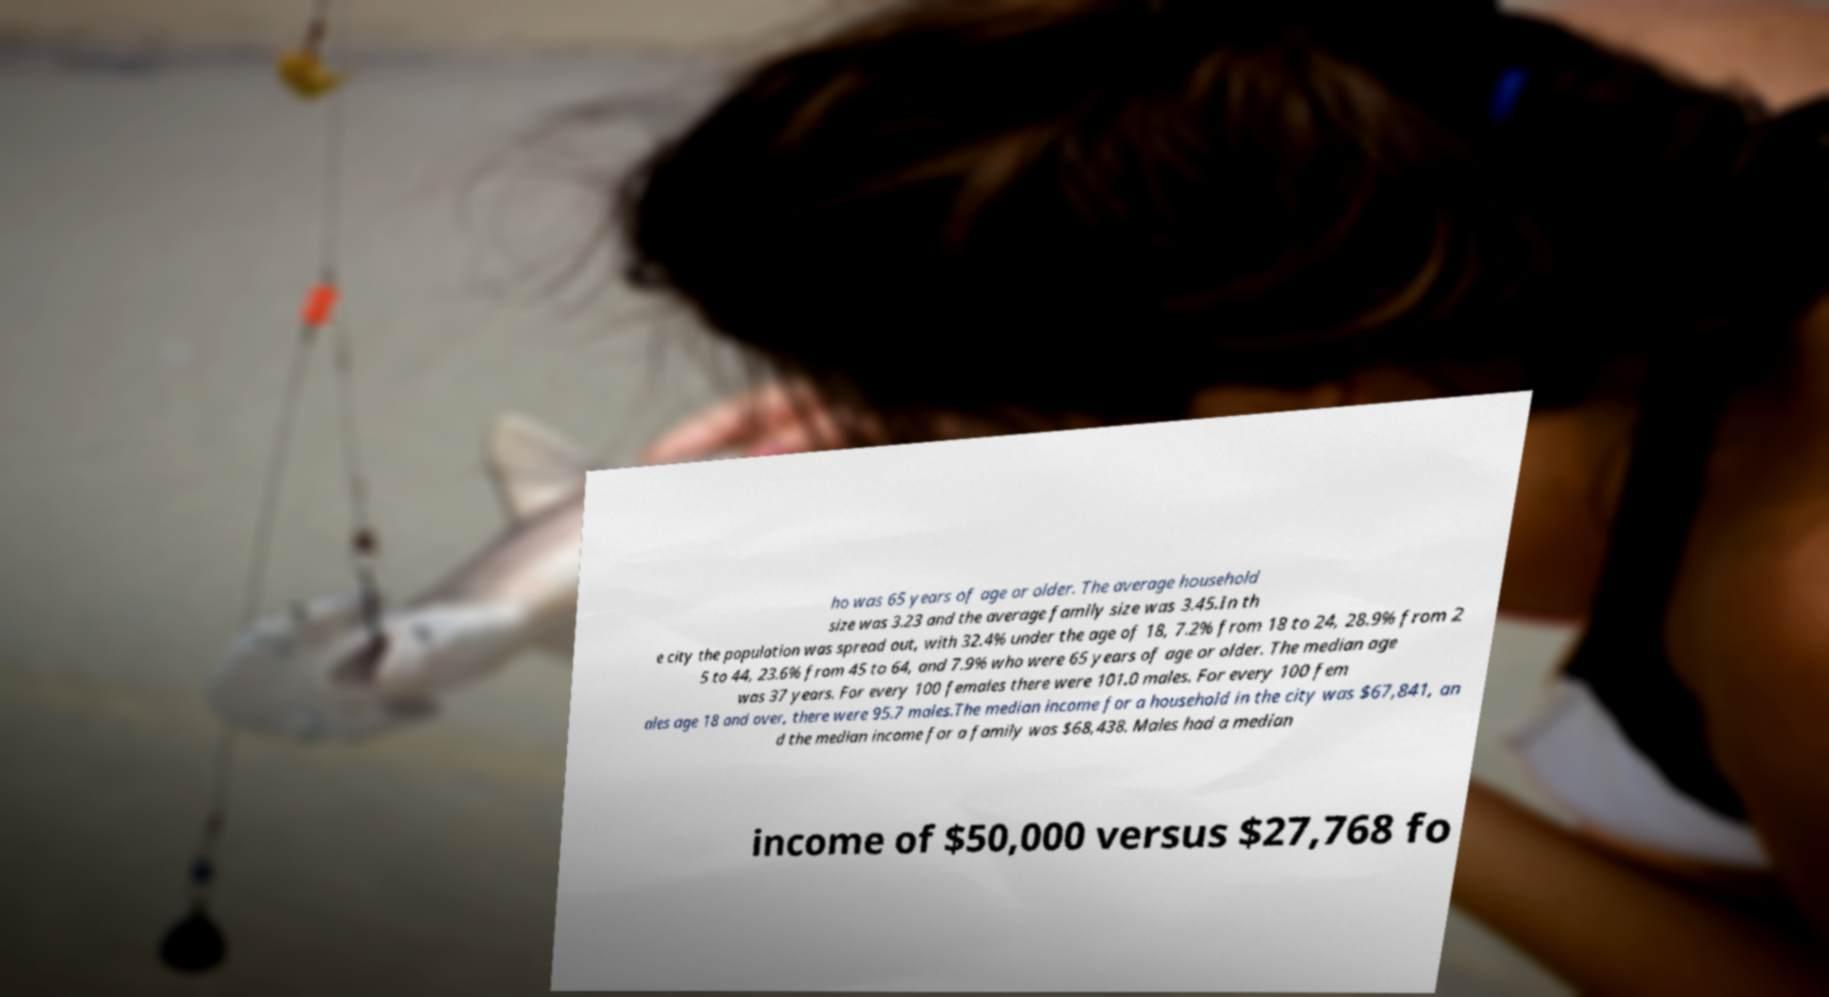Can you read and provide the text displayed in the image?This photo seems to have some interesting text. Can you extract and type it out for me? ho was 65 years of age or older. The average household size was 3.23 and the average family size was 3.45.In th e city the population was spread out, with 32.4% under the age of 18, 7.2% from 18 to 24, 28.9% from 2 5 to 44, 23.6% from 45 to 64, and 7.9% who were 65 years of age or older. The median age was 37 years. For every 100 females there were 101.0 males. For every 100 fem ales age 18 and over, there were 95.7 males.The median income for a household in the city was $67,841, an d the median income for a family was $68,438. Males had a median income of $50,000 versus $27,768 fo 